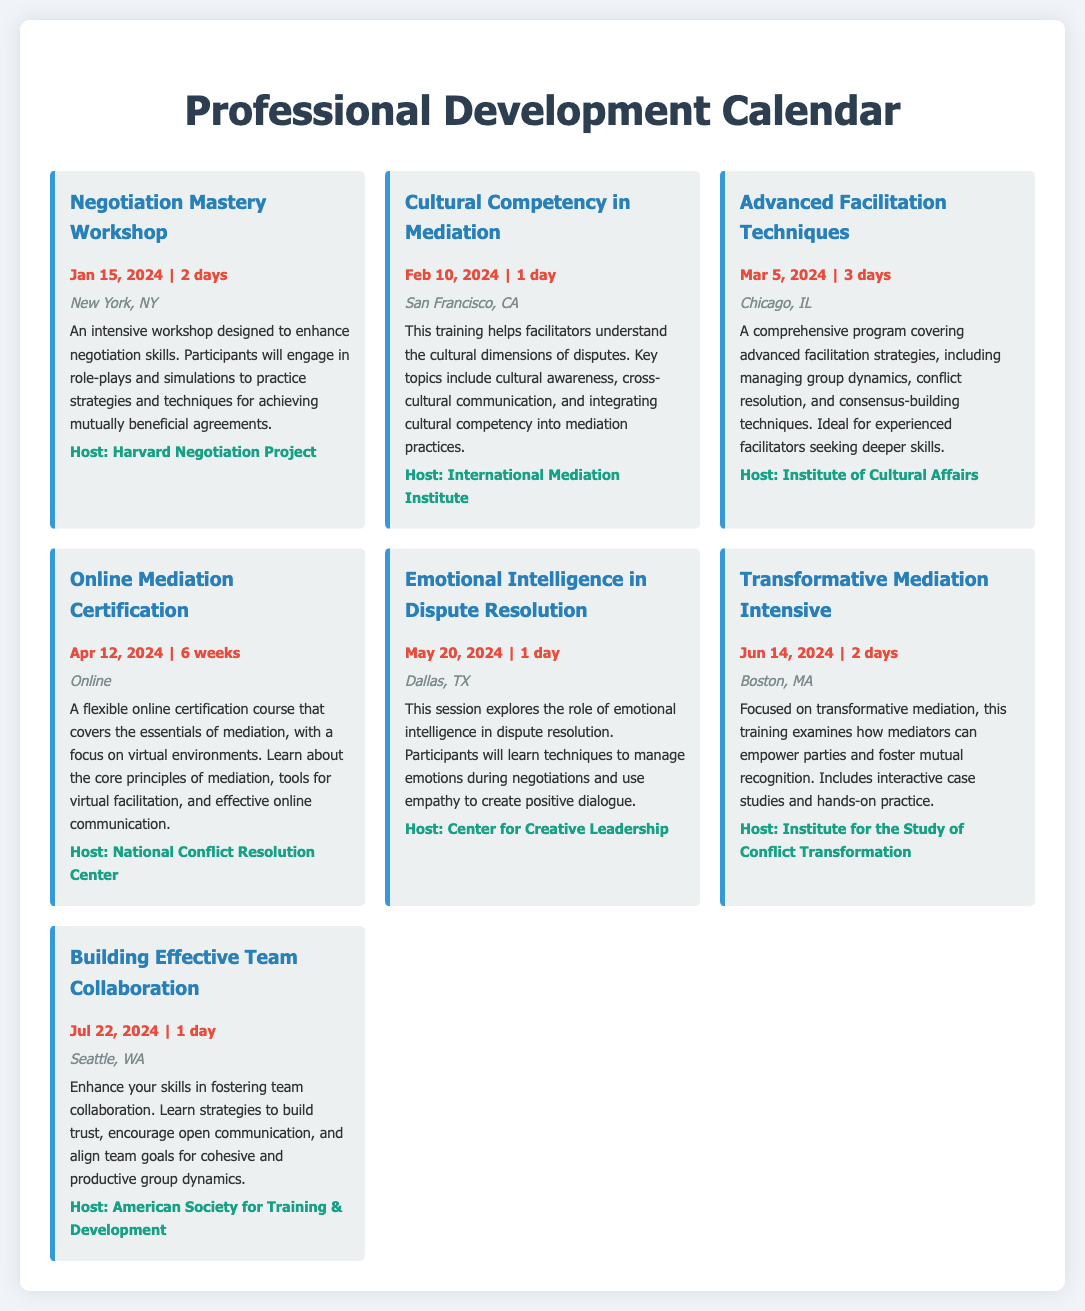What is the title of the first event? The first event listed in the document is titled "Negotiation Mastery Workshop."
Answer: Negotiation Mastery Workshop How long is the "Cultural Competency in Mediation" training? The duration of the "Cultural Competency in Mediation" training is 1 day.
Answer: 1 day What city will the "Advanced Facilitation Techniques" program be held in? The event "Advanced Facilitation Techniques" will take place in Chicago, IL.
Answer: Chicago, IL When does the "Online Mediation Certification" course begin? The course starts on April 12, 2024.
Answer: Apr 12, 2024 Which host organization is responsible for the "Emotional Intelligence in Dispute Resolution" session? The host for this session is the Center for Creative Leadership.
Answer: Center for Creative Leadership How many days is the "Transformative Mediation Intensive"? This training is scheduled for 2 days.
Answer: 2 days What is the location of the "Building Effective Team Collaboration" workshop? The workshop will be held in Seattle, WA.
Answer: Seattle, WA Identify the event focused on cultural dimensions of disputes. The event that focuses on cultural dimensions is "Cultural Competency in Mediation."
Answer: Cultural Competency in Mediation Which event lasts the longest among those listed? The "Online Mediation Certification" stands out as it lasts for 6 weeks.
Answer: 6 weeks 